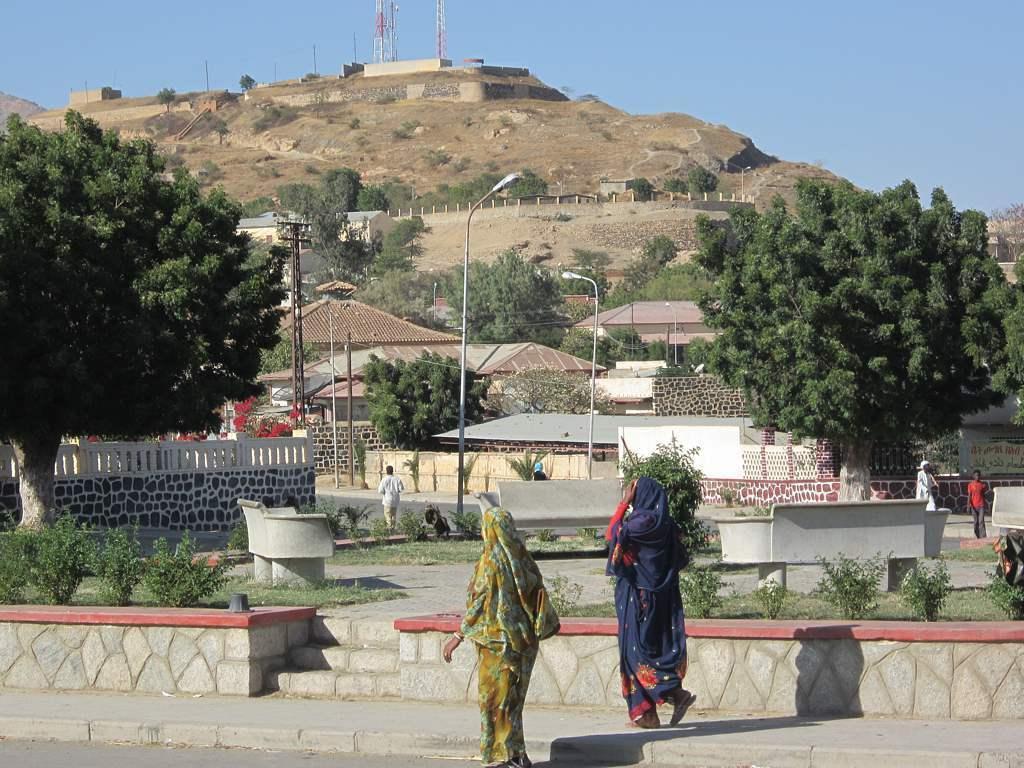In one or two sentences, can you explain what this image depicts? This picture describes about group of people, few people are walking on the pathway, in front of them we can see few plants and benches, in the background we can find few trees, poles, houses and towers. 